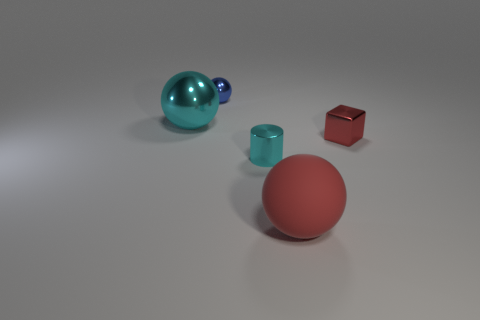How many blue shiny spheres are left of the big thing that is in front of the tiny thing right of the matte object?
Make the answer very short. 1. There is another small blue object that is the same shape as the matte object; what is it made of?
Offer a terse response. Metal. There is a object that is to the left of the red ball and in front of the cyan shiny sphere; what is it made of?
Offer a very short reply. Metal. Are there fewer red metallic blocks in front of the tiny cyan shiny thing than tiny cyan metal things in front of the large red thing?
Offer a terse response. No. What number of other objects are the same size as the matte ball?
Offer a terse response. 1. There is a big thing that is behind the big thing right of the thing that is to the left of the small ball; what is its shape?
Make the answer very short. Sphere. How many cyan objects are cylinders or large shiny spheres?
Offer a terse response. 2. There is a matte object in front of the red block; what number of cubes are on the left side of it?
Offer a very short reply. 0. Are there any other things that are the same color as the small sphere?
Offer a terse response. No. The big cyan object that is the same material as the block is what shape?
Your response must be concise. Sphere. 